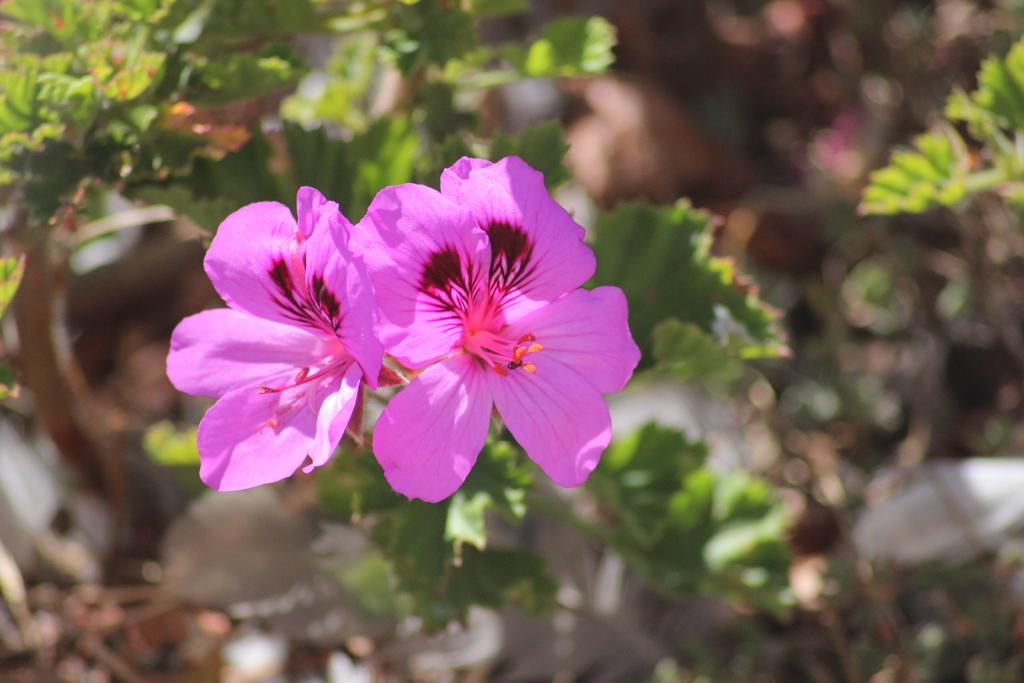How many flowers are in the image? There are two flowers in the image. What colors are the flowers? One flower is pink, and the other is yellow. Are the flowers part of a larger plant? Yes, the flowers are attached to a green plant. Can you describe the background of the image? The background of the image is blurry. What type of salt can be seen on the flowers in the image? There is no salt present on the flowers in the image. In which direction are the flowers facing in the image? The provided facts do not indicate the direction the flowers are facing. 